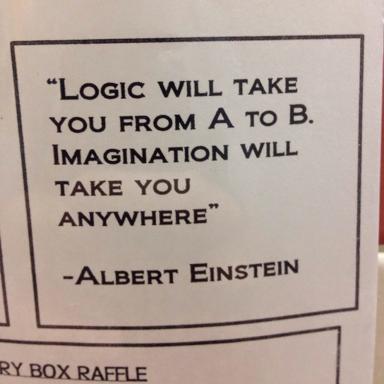How might this quote inspire someone in the field of education? In the realm of education, this quote might inspire educators and students to prioritize creativity and innovative thinking alongside logical reasoning. It serves as a reminder to embrace diverse approaches to learning and teaching, encouraging curriculums that foster imagination to solve complex problems and adapt to future challenges. 